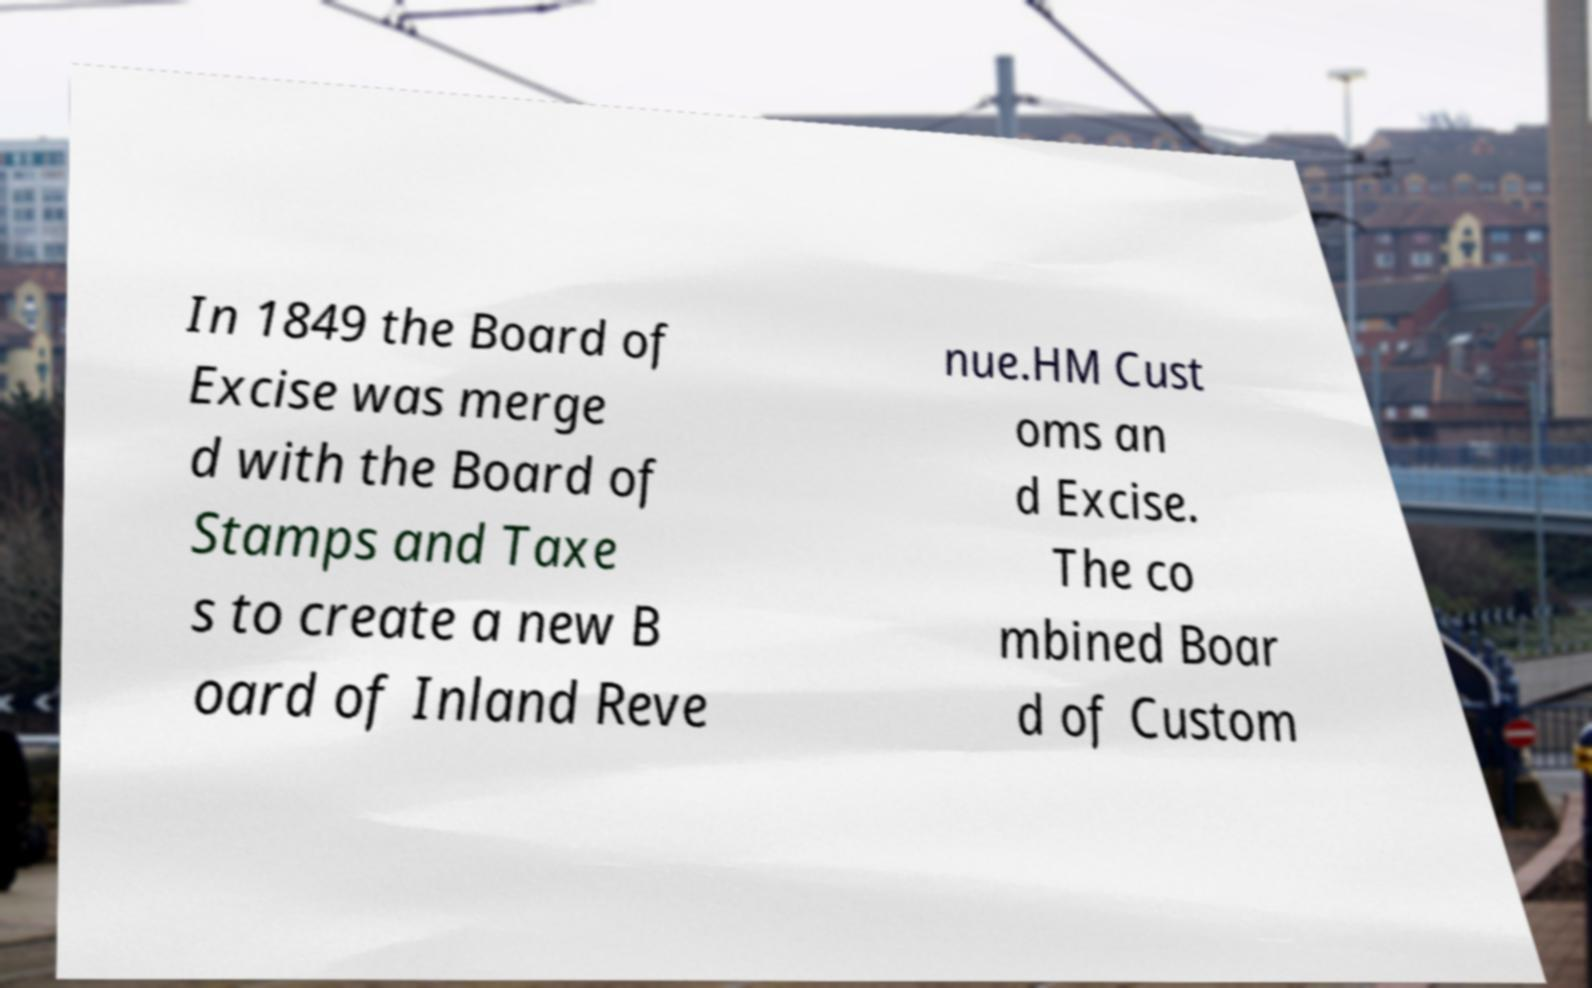I need the written content from this picture converted into text. Can you do that? In 1849 the Board of Excise was merge d with the Board of Stamps and Taxe s to create a new B oard of Inland Reve nue.HM Cust oms an d Excise. The co mbined Boar d of Custom 